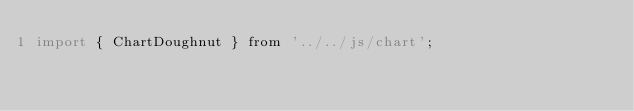Convert code to text. <code><loc_0><loc_0><loc_500><loc_500><_JavaScript_>import { ChartDoughnut } from '../../js/chart';
</code> 